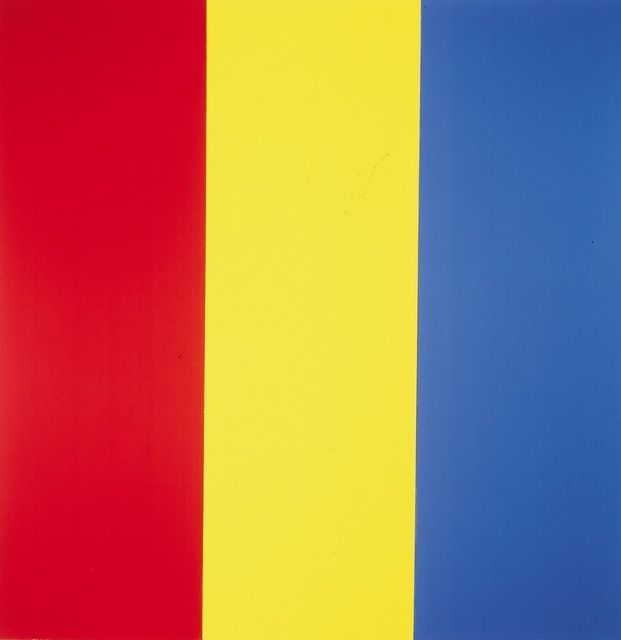If this artwork could be part of a story, what narrative would you create around it? Once upon a time in a distant realm, there was a magical prism that controlled the balance of emotions in the world. The prism was divided into three ancient pillars, each representing a fundamental emotion: Passion, Joy, and Serenity. The red pillar of Passion fueled the courage and love of the people, the yellow pillar of Joy spread laughter and brightness, while the blue pillar of Serenity brought peace and calm. The harmonious balance of these pillars maintained the world's equilibrium. One day, however, a great storm threatened to shatter the unity of the colors. It was up to a brave young artist to venture into the realm of the prism and restore the balance by painting the story of unity and harmony with the enchanted hues of the pillars. 